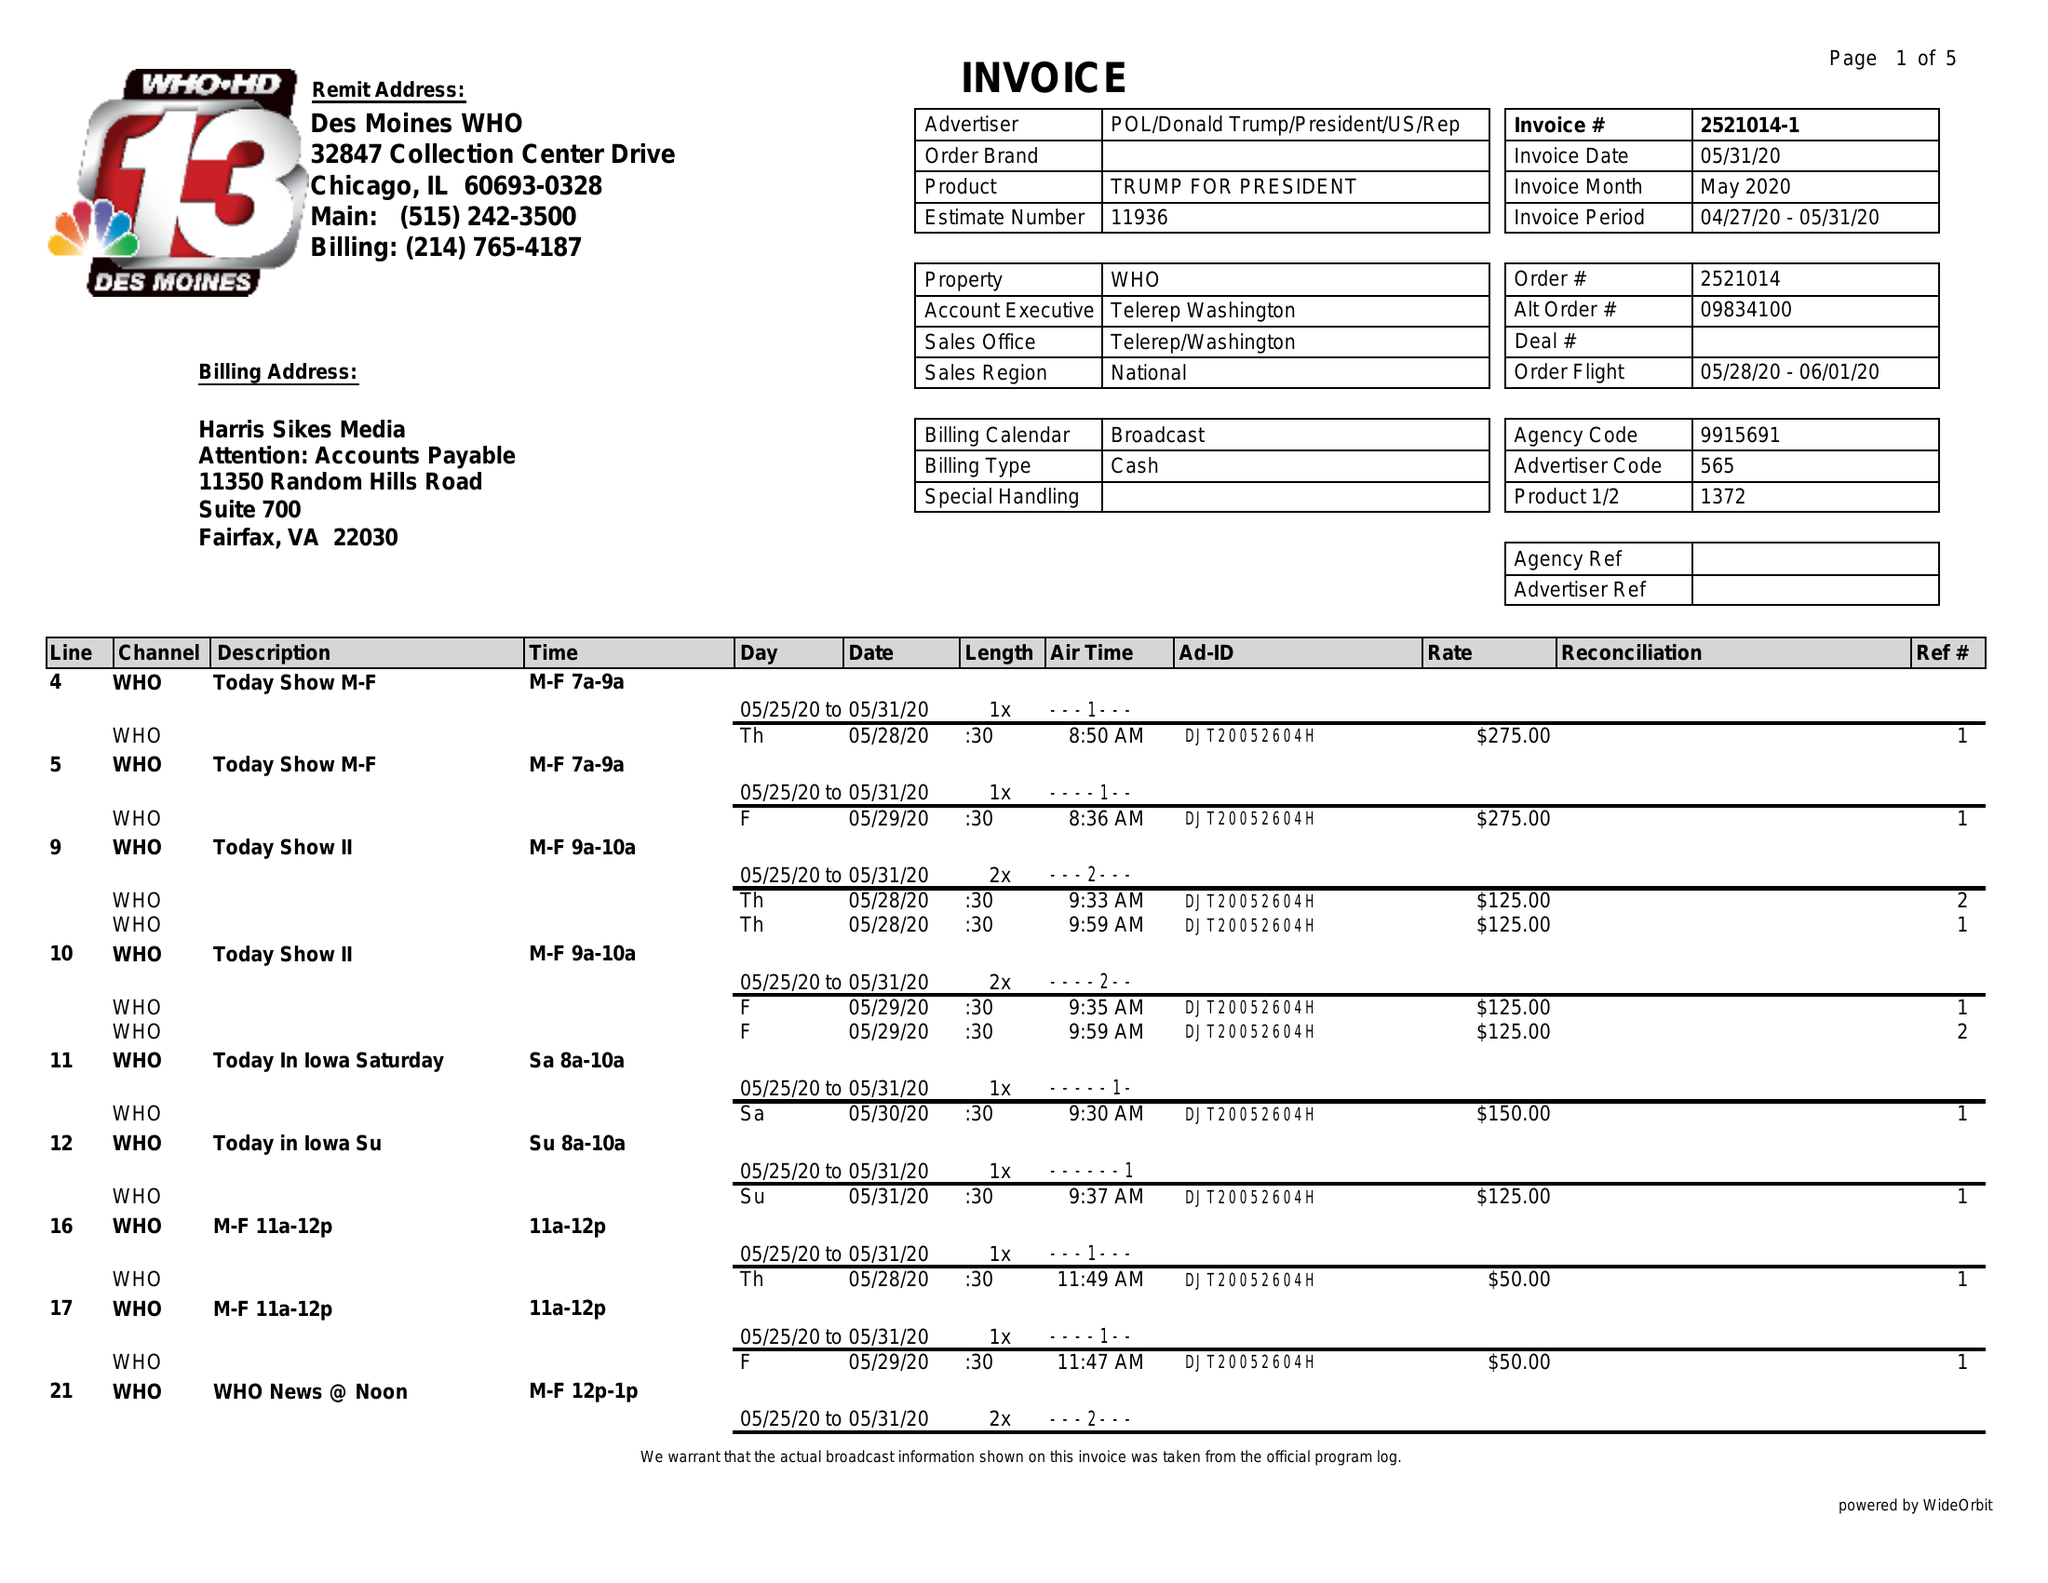What is the value for the flight_from?
Answer the question using a single word or phrase. 05/28/20 